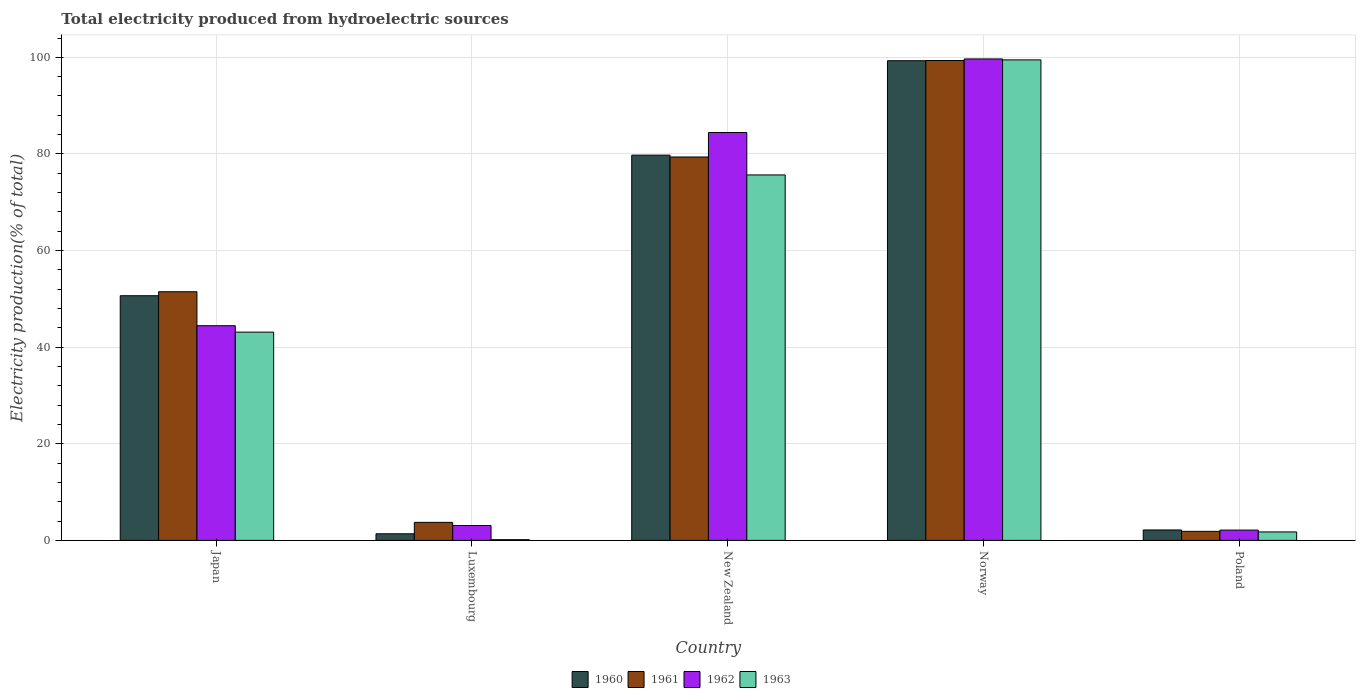Are the number of bars per tick equal to the number of legend labels?
Your response must be concise. Yes. Are the number of bars on each tick of the X-axis equal?
Your response must be concise. Yes. How many bars are there on the 3rd tick from the right?
Make the answer very short. 4. What is the label of the 1st group of bars from the left?
Give a very brief answer. Japan. In how many cases, is the number of bars for a given country not equal to the number of legend labels?
Provide a short and direct response. 0. What is the total electricity produced in 1962 in New Zealand?
Keep it short and to the point. 84.44. Across all countries, what is the maximum total electricity produced in 1962?
Your answer should be very brief. 99.67. Across all countries, what is the minimum total electricity produced in 1960?
Provide a short and direct response. 1.37. What is the total total electricity produced in 1961 in the graph?
Offer a very short reply. 235.79. What is the difference between the total electricity produced in 1963 in Japan and that in Norway?
Give a very brief answer. -56.36. What is the difference between the total electricity produced in 1961 in New Zealand and the total electricity produced in 1960 in Poland?
Offer a terse response. 77.21. What is the average total electricity produced in 1961 per country?
Give a very brief answer. 47.16. What is the difference between the total electricity produced of/in 1961 and total electricity produced of/in 1962 in Japan?
Your answer should be very brief. 7.03. In how many countries, is the total electricity produced in 1963 greater than 52 %?
Offer a terse response. 2. What is the ratio of the total electricity produced in 1963 in Japan to that in Luxembourg?
Keep it short and to the point. 292.1. Is the total electricity produced in 1961 in Japan less than that in Poland?
Offer a very short reply. No. What is the difference between the highest and the second highest total electricity produced in 1962?
Give a very brief answer. 15.23. What is the difference between the highest and the lowest total electricity produced in 1961?
Make the answer very short. 97.47. Is the sum of the total electricity produced in 1962 in Japan and Norway greater than the maximum total electricity produced in 1961 across all countries?
Your answer should be compact. Yes. Is it the case that in every country, the sum of the total electricity produced in 1961 and total electricity produced in 1960 is greater than the sum of total electricity produced in 1963 and total electricity produced in 1962?
Provide a succinct answer. No. Is it the case that in every country, the sum of the total electricity produced in 1961 and total electricity produced in 1960 is greater than the total electricity produced in 1962?
Provide a succinct answer. Yes. What is the difference between two consecutive major ticks on the Y-axis?
Offer a very short reply. 20. Does the graph contain grids?
Your response must be concise. Yes. How many legend labels are there?
Your response must be concise. 4. What is the title of the graph?
Your answer should be very brief. Total electricity produced from hydroelectric sources. What is the Electricity production(% of total) in 1960 in Japan?
Make the answer very short. 50.65. What is the Electricity production(% of total) of 1961 in Japan?
Ensure brevity in your answer.  51.48. What is the Electricity production(% of total) in 1962 in Japan?
Make the answer very short. 44.44. What is the Electricity production(% of total) in 1963 in Japan?
Offer a terse response. 43.11. What is the Electricity production(% of total) in 1960 in Luxembourg?
Provide a succinct answer. 1.37. What is the Electricity production(% of total) in 1961 in Luxembourg?
Your response must be concise. 3.73. What is the Electricity production(% of total) in 1962 in Luxembourg?
Provide a short and direct response. 3.08. What is the Electricity production(% of total) of 1963 in Luxembourg?
Keep it short and to the point. 0.15. What is the Electricity production(% of total) in 1960 in New Zealand?
Offer a very short reply. 79.75. What is the Electricity production(% of total) of 1961 in New Zealand?
Make the answer very short. 79.37. What is the Electricity production(% of total) in 1962 in New Zealand?
Ensure brevity in your answer.  84.44. What is the Electricity production(% of total) in 1963 in New Zealand?
Offer a very short reply. 75.66. What is the Electricity production(% of total) in 1960 in Norway?
Give a very brief answer. 99.3. What is the Electricity production(% of total) of 1961 in Norway?
Your answer should be compact. 99.34. What is the Electricity production(% of total) of 1962 in Norway?
Keep it short and to the point. 99.67. What is the Electricity production(% of total) in 1963 in Norway?
Provide a short and direct response. 99.47. What is the Electricity production(% of total) of 1960 in Poland?
Ensure brevity in your answer.  2.16. What is the Electricity production(% of total) in 1961 in Poland?
Your answer should be compact. 1.87. What is the Electricity production(% of total) of 1962 in Poland?
Provide a short and direct response. 2.13. What is the Electricity production(% of total) of 1963 in Poland?
Provide a short and direct response. 1.75. Across all countries, what is the maximum Electricity production(% of total) of 1960?
Give a very brief answer. 99.3. Across all countries, what is the maximum Electricity production(% of total) in 1961?
Offer a terse response. 99.34. Across all countries, what is the maximum Electricity production(% of total) of 1962?
Give a very brief answer. 99.67. Across all countries, what is the maximum Electricity production(% of total) in 1963?
Give a very brief answer. 99.47. Across all countries, what is the minimum Electricity production(% of total) in 1960?
Your response must be concise. 1.37. Across all countries, what is the minimum Electricity production(% of total) in 1961?
Provide a short and direct response. 1.87. Across all countries, what is the minimum Electricity production(% of total) of 1962?
Your answer should be compact. 2.13. Across all countries, what is the minimum Electricity production(% of total) in 1963?
Make the answer very short. 0.15. What is the total Electricity production(% of total) of 1960 in the graph?
Ensure brevity in your answer.  233.22. What is the total Electricity production(% of total) of 1961 in the graph?
Offer a very short reply. 235.79. What is the total Electricity production(% of total) in 1962 in the graph?
Make the answer very short. 233.77. What is the total Electricity production(% of total) in 1963 in the graph?
Ensure brevity in your answer.  220.15. What is the difference between the Electricity production(% of total) of 1960 in Japan and that in Luxembourg?
Make the answer very short. 49.28. What is the difference between the Electricity production(% of total) of 1961 in Japan and that in Luxembourg?
Provide a succinct answer. 47.75. What is the difference between the Electricity production(% of total) in 1962 in Japan and that in Luxembourg?
Keep it short and to the point. 41.36. What is the difference between the Electricity production(% of total) in 1963 in Japan and that in Luxembourg?
Provide a succinct answer. 42.97. What is the difference between the Electricity production(% of total) in 1960 in Japan and that in New Zealand?
Ensure brevity in your answer.  -29.1. What is the difference between the Electricity production(% of total) of 1961 in Japan and that in New Zealand?
Your response must be concise. -27.9. What is the difference between the Electricity production(% of total) of 1962 in Japan and that in New Zealand?
Give a very brief answer. -39.99. What is the difference between the Electricity production(% of total) in 1963 in Japan and that in New Zealand?
Provide a short and direct response. -32.54. What is the difference between the Electricity production(% of total) in 1960 in Japan and that in Norway?
Provide a succinct answer. -48.65. What is the difference between the Electricity production(% of total) in 1961 in Japan and that in Norway?
Give a very brief answer. -47.87. What is the difference between the Electricity production(% of total) of 1962 in Japan and that in Norway?
Offer a very short reply. -55.23. What is the difference between the Electricity production(% of total) in 1963 in Japan and that in Norway?
Provide a short and direct response. -56.36. What is the difference between the Electricity production(% of total) in 1960 in Japan and that in Poland?
Your response must be concise. 48.49. What is the difference between the Electricity production(% of total) of 1961 in Japan and that in Poland?
Your answer should be compact. 49.6. What is the difference between the Electricity production(% of total) in 1962 in Japan and that in Poland?
Offer a terse response. 42.31. What is the difference between the Electricity production(% of total) of 1963 in Japan and that in Poland?
Provide a short and direct response. 41.36. What is the difference between the Electricity production(% of total) in 1960 in Luxembourg and that in New Zealand?
Provide a short and direct response. -78.38. What is the difference between the Electricity production(% of total) of 1961 in Luxembourg and that in New Zealand?
Keep it short and to the point. -75.64. What is the difference between the Electricity production(% of total) in 1962 in Luxembourg and that in New Zealand?
Offer a very short reply. -81.36. What is the difference between the Electricity production(% of total) of 1963 in Luxembourg and that in New Zealand?
Ensure brevity in your answer.  -75.51. What is the difference between the Electricity production(% of total) in 1960 in Luxembourg and that in Norway?
Your response must be concise. -97.93. What is the difference between the Electricity production(% of total) of 1961 in Luxembourg and that in Norway?
Your answer should be compact. -95.61. What is the difference between the Electricity production(% of total) in 1962 in Luxembourg and that in Norway?
Your answer should be compact. -96.59. What is the difference between the Electricity production(% of total) of 1963 in Luxembourg and that in Norway?
Ensure brevity in your answer.  -99.33. What is the difference between the Electricity production(% of total) in 1960 in Luxembourg and that in Poland?
Give a very brief answer. -0.79. What is the difference between the Electricity production(% of total) of 1961 in Luxembourg and that in Poland?
Your answer should be compact. 1.86. What is the difference between the Electricity production(% of total) of 1962 in Luxembourg and that in Poland?
Keep it short and to the point. 0.95. What is the difference between the Electricity production(% of total) in 1963 in Luxembourg and that in Poland?
Your response must be concise. -1.6. What is the difference between the Electricity production(% of total) of 1960 in New Zealand and that in Norway?
Give a very brief answer. -19.55. What is the difference between the Electricity production(% of total) in 1961 in New Zealand and that in Norway?
Your answer should be very brief. -19.97. What is the difference between the Electricity production(% of total) of 1962 in New Zealand and that in Norway?
Provide a short and direct response. -15.23. What is the difference between the Electricity production(% of total) in 1963 in New Zealand and that in Norway?
Provide a succinct answer. -23.82. What is the difference between the Electricity production(% of total) of 1960 in New Zealand and that in Poland?
Your response must be concise. 77.59. What is the difference between the Electricity production(% of total) of 1961 in New Zealand and that in Poland?
Make the answer very short. 77.5. What is the difference between the Electricity production(% of total) in 1962 in New Zealand and that in Poland?
Make the answer very short. 82.31. What is the difference between the Electricity production(% of total) of 1963 in New Zealand and that in Poland?
Give a very brief answer. 73.91. What is the difference between the Electricity production(% of total) in 1960 in Norway and that in Poland?
Provide a succinct answer. 97.14. What is the difference between the Electricity production(% of total) in 1961 in Norway and that in Poland?
Give a very brief answer. 97.47. What is the difference between the Electricity production(% of total) of 1962 in Norway and that in Poland?
Make the answer very short. 97.54. What is the difference between the Electricity production(% of total) in 1963 in Norway and that in Poland?
Give a very brief answer. 97.72. What is the difference between the Electricity production(% of total) of 1960 in Japan and the Electricity production(% of total) of 1961 in Luxembourg?
Offer a very short reply. 46.92. What is the difference between the Electricity production(% of total) in 1960 in Japan and the Electricity production(% of total) in 1962 in Luxembourg?
Your answer should be compact. 47.57. What is the difference between the Electricity production(% of total) in 1960 in Japan and the Electricity production(% of total) in 1963 in Luxembourg?
Offer a terse response. 50.5. What is the difference between the Electricity production(% of total) of 1961 in Japan and the Electricity production(% of total) of 1962 in Luxembourg?
Your answer should be compact. 48.39. What is the difference between the Electricity production(% of total) in 1961 in Japan and the Electricity production(% of total) in 1963 in Luxembourg?
Keep it short and to the point. 51.33. What is the difference between the Electricity production(% of total) of 1962 in Japan and the Electricity production(% of total) of 1963 in Luxembourg?
Offer a terse response. 44.3. What is the difference between the Electricity production(% of total) of 1960 in Japan and the Electricity production(% of total) of 1961 in New Zealand?
Ensure brevity in your answer.  -28.72. What is the difference between the Electricity production(% of total) in 1960 in Japan and the Electricity production(% of total) in 1962 in New Zealand?
Give a very brief answer. -33.79. What is the difference between the Electricity production(% of total) of 1960 in Japan and the Electricity production(% of total) of 1963 in New Zealand?
Your answer should be very brief. -25.01. What is the difference between the Electricity production(% of total) of 1961 in Japan and the Electricity production(% of total) of 1962 in New Zealand?
Provide a succinct answer. -32.96. What is the difference between the Electricity production(% of total) of 1961 in Japan and the Electricity production(% of total) of 1963 in New Zealand?
Provide a short and direct response. -24.18. What is the difference between the Electricity production(% of total) in 1962 in Japan and the Electricity production(% of total) in 1963 in New Zealand?
Ensure brevity in your answer.  -31.21. What is the difference between the Electricity production(% of total) of 1960 in Japan and the Electricity production(% of total) of 1961 in Norway?
Offer a very short reply. -48.69. What is the difference between the Electricity production(% of total) in 1960 in Japan and the Electricity production(% of total) in 1962 in Norway?
Offer a terse response. -49.02. What is the difference between the Electricity production(% of total) of 1960 in Japan and the Electricity production(% of total) of 1963 in Norway?
Make the answer very short. -48.83. What is the difference between the Electricity production(% of total) in 1961 in Japan and the Electricity production(% of total) in 1962 in Norway?
Make the answer very short. -48.19. What is the difference between the Electricity production(% of total) of 1961 in Japan and the Electricity production(% of total) of 1963 in Norway?
Offer a terse response. -48. What is the difference between the Electricity production(% of total) of 1962 in Japan and the Electricity production(% of total) of 1963 in Norway?
Provide a short and direct response. -55.03. What is the difference between the Electricity production(% of total) in 1960 in Japan and the Electricity production(% of total) in 1961 in Poland?
Offer a terse response. 48.78. What is the difference between the Electricity production(% of total) in 1960 in Japan and the Electricity production(% of total) in 1962 in Poland?
Make the answer very short. 48.52. What is the difference between the Electricity production(% of total) of 1960 in Japan and the Electricity production(% of total) of 1963 in Poland?
Keep it short and to the point. 48.9. What is the difference between the Electricity production(% of total) of 1961 in Japan and the Electricity production(% of total) of 1962 in Poland?
Your response must be concise. 49.34. What is the difference between the Electricity production(% of total) of 1961 in Japan and the Electricity production(% of total) of 1963 in Poland?
Provide a short and direct response. 49.72. What is the difference between the Electricity production(% of total) in 1962 in Japan and the Electricity production(% of total) in 1963 in Poland?
Offer a very short reply. 42.69. What is the difference between the Electricity production(% of total) in 1960 in Luxembourg and the Electricity production(% of total) in 1961 in New Zealand?
Provide a short and direct response. -78.01. What is the difference between the Electricity production(% of total) of 1960 in Luxembourg and the Electricity production(% of total) of 1962 in New Zealand?
Provide a short and direct response. -83.07. What is the difference between the Electricity production(% of total) of 1960 in Luxembourg and the Electricity production(% of total) of 1963 in New Zealand?
Your response must be concise. -74.29. What is the difference between the Electricity production(% of total) of 1961 in Luxembourg and the Electricity production(% of total) of 1962 in New Zealand?
Your response must be concise. -80.71. What is the difference between the Electricity production(% of total) in 1961 in Luxembourg and the Electricity production(% of total) in 1963 in New Zealand?
Provide a succinct answer. -71.93. What is the difference between the Electricity production(% of total) of 1962 in Luxembourg and the Electricity production(% of total) of 1963 in New Zealand?
Offer a terse response. -72.58. What is the difference between the Electricity production(% of total) in 1960 in Luxembourg and the Electricity production(% of total) in 1961 in Norway?
Offer a very short reply. -97.98. What is the difference between the Electricity production(% of total) in 1960 in Luxembourg and the Electricity production(% of total) in 1962 in Norway?
Offer a very short reply. -98.3. What is the difference between the Electricity production(% of total) of 1960 in Luxembourg and the Electricity production(% of total) of 1963 in Norway?
Make the answer very short. -98.11. What is the difference between the Electricity production(% of total) in 1961 in Luxembourg and the Electricity production(% of total) in 1962 in Norway?
Offer a very short reply. -95.94. What is the difference between the Electricity production(% of total) of 1961 in Luxembourg and the Electricity production(% of total) of 1963 in Norway?
Provide a short and direct response. -95.74. What is the difference between the Electricity production(% of total) of 1962 in Luxembourg and the Electricity production(% of total) of 1963 in Norway?
Offer a very short reply. -96.39. What is the difference between the Electricity production(% of total) in 1960 in Luxembourg and the Electricity production(% of total) in 1961 in Poland?
Your response must be concise. -0.51. What is the difference between the Electricity production(% of total) in 1960 in Luxembourg and the Electricity production(% of total) in 1962 in Poland?
Offer a terse response. -0.77. What is the difference between the Electricity production(% of total) of 1960 in Luxembourg and the Electricity production(% of total) of 1963 in Poland?
Offer a terse response. -0.39. What is the difference between the Electricity production(% of total) in 1961 in Luxembourg and the Electricity production(% of total) in 1962 in Poland?
Provide a succinct answer. 1.6. What is the difference between the Electricity production(% of total) of 1961 in Luxembourg and the Electricity production(% of total) of 1963 in Poland?
Offer a very short reply. 1.98. What is the difference between the Electricity production(% of total) in 1962 in Luxembourg and the Electricity production(% of total) in 1963 in Poland?
Give a very brief answer. 1.33. What is the difference between the Electricity production(% of total) of 1960 in New Zealand and the Electricity production(% of total) of 1961 in Norway?
Give a very brief answer. -19.59. What is the difference between the Electricity production(% of total) of 1960 in New Zealand and the Electricity production(% of total) of 1962 in Norway?
Your answer should be very brief. -19.92. What is the difference between the Electricity production(% of total) of 1960 in New Zealand and the Electricity production(% of total) of 1963 in Norway?
Keep it short and to the point. -19.72. What is the difference between the Electricity production(% of total) in 1961 in New Zealand and the Electricity production(% of total) in 1962 in Norway?
Give a very brief answer. -20.3. What is the difference between the Electricity production(% of total) in 1961 in New Zealand and the Electricity production(% of total) in 1963 in Norway?
Your answer should be compact. -20.1. What is the difference between the Electricity production(% of total) of 1962 in New Zealand and the Electricity production(% of total) of 1963 in Norway?
Make the answer very short. -15.04. What is the difference between the Electricity production(% of total) in 1960 in New Zealand and the Electricity production(% of total) in 1961 in Poland?
Your answer should be very brief. 77.88. What is the difference between the Electricity production(% of total) of 1960 in New Zealand and the Electricity production(% of total) of 1962 in Poland?
Offer a terse response. 77.62. What is the difference between the Electricity production(% of total) in 1960 in New Zealand and the Electricity production(% of total) in 1963 in Poland?
Provide a short and direct response. 78. What is the difference between the Electricity production(% of total) of 1961 in New Zealand and the Electricity production(% of total) of 1962 in Poland?
Offer a terse response. 77.24. What is the difference between the Electricity production(% of total) in 1961 in New Zealand and the Electricity production(% of total) in 1963 in Poland?
Provide a short and direct response. 77.62. What is the difference between the Electricity production(% of total) in 1962 in New Zealand and the Electricity production(% of total) in 1963 in Poland?
Make the answer very short. 82.69. What is the difference between the Electricity production(% of total) in 1960 in Norway and the Electricity production(% of total) in 1961 in Poland?
Your response must be concise. 97.43. What is the difference between the Electricity production(% of total) of 1960 in Norway and the Electricity production(% of total) of 1962 in Poland?
Provide a short and direct response. 97.17. What is the difference between the Electricity production(% of total) in 1960 in Norway and the Electricity production(% of total) in 1963 in Poland?
Offer a terse response. 97.55. What is the difference between the Electricity production(% of total) in 1961 in Norway and the Electricity production(% of total) in 1962 in Poland?
Give a very brief answer. 97.21. What is the difference between the Electricity production(% of total) in 1961 in Norway and the Electricity production(% of total) in 1963 in Poland?
Your response must be concise. 97.59. What is the difference between the Electricity production(% of total) of 1962 in Norway and the Electricity production(% of total) of 1963 in Poland?
Keep it short and to the point. 97.92. What is the average Electricity production(% of total) of 1960 per country?
Your answer should be compact. 46.65. What is the average Electricity production(% of total) of 1961 per country?
Provide a short and direct response. 47.16. What is the average Electricity production(% of total) of 1962 per country?
Make the answer very short. 46.75. What is the average Electricity production(% of total) in 1963 per country?
Provide a succinct answer. 44.03. What is the difference between the Electricity production(% of total) of 1960 and Electricity production(% of total) of 1961 in Japan?
Your answer should be compact. -0.83. What is the difference between the Electricity production(% of total) in 1960 and Electricity production(% of total) in 1962 in Japan?
Your response must be concise. 6.2. What is the difference between the Electricity production(% of total) of 1960 and Electricity production(% of total) of 1963 in Japan?
Your response must be concise. 7.54. What is the difference between the Electricity production(% of total) of 1961 and Electricity production(% of total) of 1962 in Japan?
Give a very brief answer. 7.03. What is the difference between the Electricity production(% of total) of 1961 and Electricity production(% of total) of 1963 in Japan?
Provide a short and direct response. 8.36. What is the difference between the Electricity production(% of total) of 1962 and Electricity production(% of total) of 1963 in Japan?
Ensure brevity in your answer.  1.33. What is the difference between the Electricity production(% of total) of 1960 and Electricity production(% of total) of 1961 in Luxembourg?
Your response must be concise. -2.36. What is the difference between the Electricity production(% of total) in 1960 and Electricity production(% of total) in 1962 in Luxembourg?
Keep it short and to the point. -1.72. What is the difference between the Electricity production(% of total) of 1960 and Electricity production(% of total) of 1963 in Luxembourg?
Provide a short and direct response. 1.22. What is the difference between the Electricity production(% of total) of 1961 and Electricity production(% of total) of 1962 in Luxembourg?
Your answer should be compact. 0.65. What is the difference between the Electricity production(% of total) of 1961 and Electricity production(% of total) of 1963 in Luxembourg?
Offer a terse response. 3.58. What is the difference between the Electricity production(% of total) in 1962 and Electricity production(% of total) in 1963 in Luxembourg?
Provide a succinct answer. 2.93. What is the difference between the Electricity production(% of total) in 1960 and Electricity production(% of total) in 1961 in New Zealand?
Your response must be concise. 0.38. What is the difference between the Electricity production(% of total) in 1960 and Electricity production(% of total) in 1962 in New Zealand?
Your response must be concise. -4.69. What is the difference between the Electricity production(% of total) of 1960 and Electricity production(% of total) of 1963 in New Zealand?
Provide a short and direct response. 4.09. What is the difference between the Electricity production(% of total) of 1961 and Electricity production(% of total) of 1962 in New Zealand?
Ensure brevity in your answer.  -5.07. What is the difference between the Electricity production(% of total) of 1961 and Electricity production(% of total) of 1963 in New Zealand?
Make the answer very short. 3.71. What is the difference between the Electricity production(% of total) of 1962 and Electricity production(% of total) of 1963 in New Zealand?
Make the answer very short. 8.78. What is the difference between the Electricity production(% of total) of 1960 and Electricity production(% of total) of 1961 in Norway?
Give a very brief answer. -0.04. What is the difference between the Electricity production(% of total) of 1960 and Electricity production(% of total) of 1962 in Norway?
Give a very brief answer. -0.37. What is the difference between the Electricity production(% of total) of 1960 and Electricity production(% of total) of 1963 in Norway?
Keep it short and to the point. -0.17. What is the difference between the Electricity production(% of total) in 1961 and Electricity production(% of total) in 1962 in Norway?
Provide a short and direct response. -0.33. What is the difference between the Electricity production(% of total) in 1961 and Electricity production(% of total) in 1963 in Norway?
Keep it short and to the point. -0.13. What is the difference between the Electricity production(% of total) in 1962 and Electricity production(% of total) in 1963 in Norway?
Your response must be concise. 0.19. What is the difference between the Electricity production(% of total) in 1960 and Electricity production(% of total) in 1961 in Poland?
Offer a terse response. 0.28. What is the difference between the Electricity production(% of total) of 1960 and Electricity production(% of total) of 1962 in Poland?
Offer a very short reply. 0.03. What is the difference between the Electricity production(% of total) of 1960 and Electricity production(% of total) of 1963 in Poland?
Ensure brevity in your answer.  0.41. What is the difference between the Electricity production(% of total) of 1961 and Electricity production(% of total) of 1962 in Poland?
Make the answer very short. -0.26. What is the difference between the Electricity production(% of total) in 1961 and Electricity production(% of total) in 1963 in Poland?
Ensure brevity in your answer.  0.12. What is the difference between the Electricity production(% of total) of 1962 and Electricity production(% of total) of 1963 in Poland?
Give a very brief answer. 0.38. What is the ratio of the Electricity production(% of total) in 1960 in Japan to that in Luxembourg?
Your response must be concise. 37.08. What is the ratio of the Electricity production(% of total) in 1961 in Japan to that in Luxembourg?
Keep it short and to the point. 13.8. What is the ratio of the Electricity production(% of total) of 1962 in Japan to that in Luxembourg?
Your answer should be very brief. 14.42. What is the ratio of the Electricity production(% of total) of 1963 in Japan to that in Luxembourg?
Make the answer very short. 292.1. What is the ratio of the Electricity production(% of total) in 1960 in Japan to that in New Zealand?
Your answer should be very brief. 0.64. What is the ratio of the Electricity production(% of total) of 1961 in Japan to that in New Zealand?
Make the answer very short. 0.65. What is the ratio of the Electricity production(% of total) in 1962 in Japan to that in New Zealand?
Offer a very short reply. 0.53. What is the ratio of the Electricity production(% of total) in 1963 in Japan to that in New Zealand?
Keep it short and to the point. 0.57. What is the ratio of the Electricity production(% of total) of 1960 in Japan to that in Norway?
Your answer should be compact. 0.51. What is the ratio of the Electricity production(% of total) of 1961 in Japan to that in Norway?
Give a very brief answer. 0.52. What is the ratio of the Electricity production(% of total) of 1962 in Japan to that in Norway?
Provide a short and direct response. 0.45. What is the ratio of the Electricity production(% of total) in 1963 in Japan to that in Norway?
Your answer should be compact. 0.43. What is the ratio of the Electricity production(% of total) of 1960 in Japan to that in Poland?
Offer a terse response. 23.47. What is the ratio of the Electricity production(% of total) in 1961 in Japan to that in Poland?
Offer a very short reply. 27.48. What is the ratio of the Electricity production(% of total) in 1962 in Japan to that in Poland?
Your response must be concise. 20.85. What is the ratio of the Electricity production(% of total) in 1963 in Japan to that in Poland?
Give a very brief answer. 24.62. What is the ratio of the Electricity production(% of total) of 1960 in Luxembourg to that in New Zealand?
Provide a short and direct response. 0.02. What is the ratio of the Electricity production(% of total) in 1961 in Luxembourg to that in New Zealand?
Keep it short and to the point. 0.05. What is the ratio of the Electricity production(% of total) in 1962 in Luxembourg to that in New Zealand?
Offer a very short reply. 0.04. What is the ratio of the Electricity production(% of total) in 1963 in Luxembourg to that in New Zealand?
Your response must be concise. 0. What is the ratio of the Electricity production(% of total) of 1960 in Luxembourg to that in Norway?
Make the answer very short. 0.01. What is the ratio of the Electricity production(% of total) in 1961 in Luxembourg to that in Norway?
Your response must be concise. 0.04. What is the ratio of the Electricity production(% of total) of 1962 in Luxembourg to that in Norway?
Ensure brevity in your answer.  0.03. What is the ratio of the Electricity production(% of total) of 1963 in Luxembourg to that in Norway?
Your answer should be very brief. 0. What is the ratio of the Electricity production(% of total) of 1960 in Luxembourg to that in Poland?
Make the answer very short. 0.63. What is the ratio of the Electricity production(% of total) of 1961 in Luxembourg to that in Poland?
Offer a terse response. 1.99. What is the ratio of the Electricity production(% of total) in 1962 in Luxembourg to that in Poland?
Give a very brief answer. 1.45. What is the ratio of the Electricity production(% of total) of 1963 in Luxembourg to that in Poland?
Offer a terse response. 0.08. What is the ratio of the Electricity production(% of total) in 1960 in New Zealand to that in Norway?
Provide a succinct answer. 0.8. What is the ratio of the Electricity production(% of total) in 1961 in New Zealand to that in Norway?
Give a very brief answer. 0.8. What is the ratio of the Electricity production(% of total) in 1962 in New Zealand to that in Norway?
Your answer should be very brief. 0.85. What is the ratio of the Electricity production(% of total) of 1963 in New Zealand to that in Norway?
Give a very brief answer. 0.76. What is the ratio of the Electricity production(% of total) in 1960 in New Zealand to that in Poland?
Ensure brevity in your answer.  36.95. What is the ratio of the Electricity production(% of total) in 1961 in New Zealand to that in Poland?
Provide a succinct answer. 42.37. What is the ratio of the Electricity production(% of total) of 1962 in New Zealand to that in Poland?
Your response must be concise. 39.6. What is the ratio of the Electricity production(% of total) of 1963 in New Zealand to that in Poland?
Your answer should be compact. 43.2. What is the ratio of the Electricity production(% of total) in 1960 in Norway to that in Poland?
Your answer should be very brief. 46.01. What is the ratio of the Electricity production(% of total) of 1961 in Norway to that in Poland?
Your answer should be compact. 53.03. What is the ratio of the Electricity production(% of total) in 1962 in Norway to that in Poland?
Ensure brevity in your answer.  46.75. What is the ratio of the Electricity production(% of total) of 1963 in Norway to that in Poland?
Your response must be concise. 56.8. What is the difference between the highest and the second highest Electricity production(% of total) of 1960?
Provide a succinct answer. 19.55. What is the difference between the highest and the second highest Electricity production(% of total) in 1961?
Provide a succinct answer. 19.97. What is the difference between the highest and the second highest Electricity production(% of total) in 1962?
Ensure brevity in your answer.  15.23. What is the difference between the highest and the second highest Electricity production(% of total) in 1963?
Make the answer very short. 23.82. What is the difference between the highest and the lowest Electricity production(% of total) of 1960?
Your answer should be compact. 97.93. What is the difference between the highest and the lowest Electricity production(% of total) of 1961?
Your answer should be compact. 97.47. What is the difference between the highest and the lowest Electricity production(% of total) of 1962?
Give a very brief answer. 97.54. What is the difference between the highest and the lowest Electricity production(% of total) in 1963?
Give a very brief answer. 99.33. 